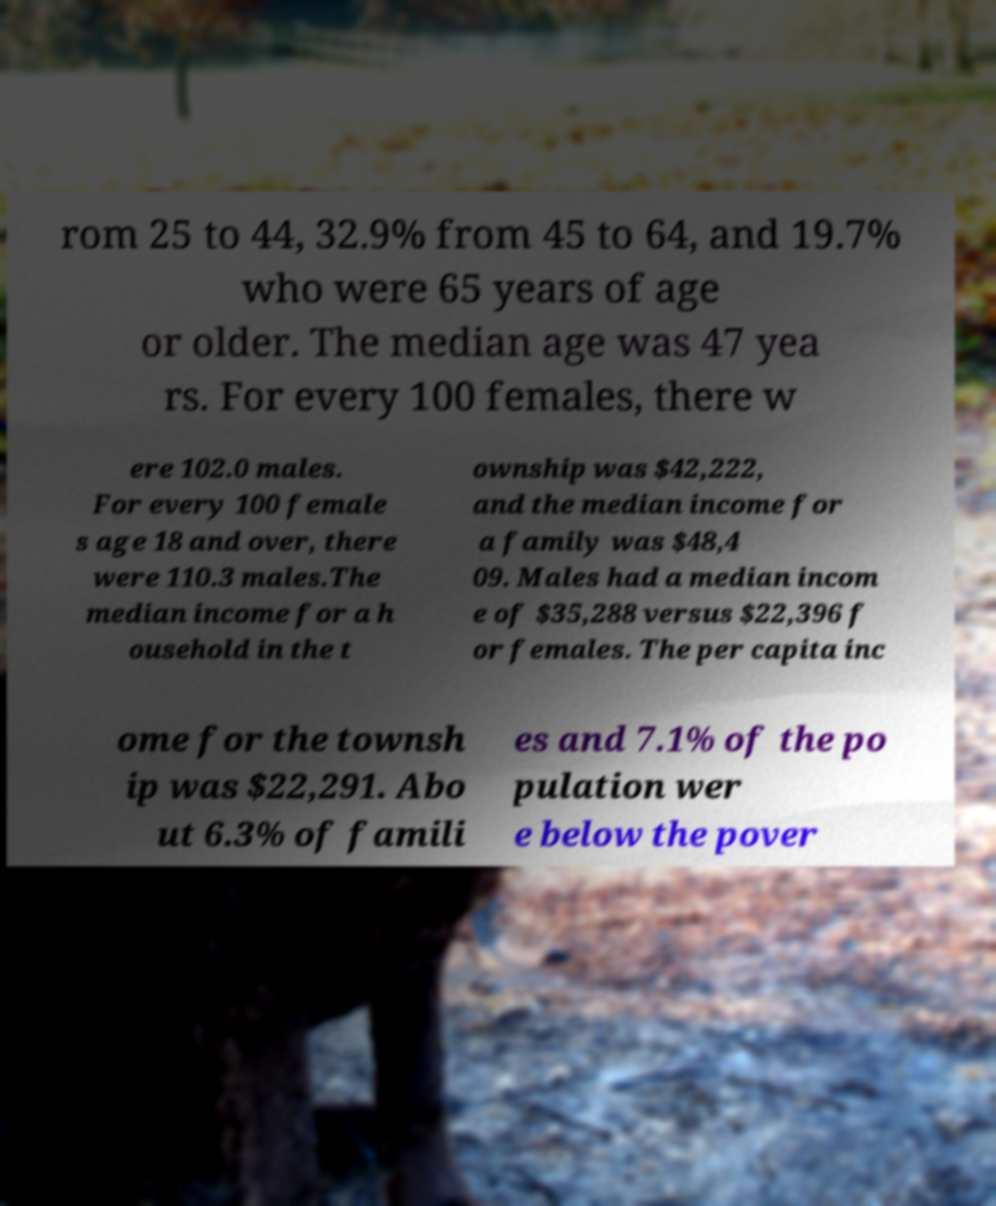I need the written content from this picture converted into text. Can you do that? rom 25 to 44, 32.9% from 45 to 64, and 19.7% who were 65 years of age or older. The median age was 47 yea rs. For every 100 females, there w ere 102.0 males. For every 100 female s age 18 and over, there were 110.3 males.The median income for a h ousehold in the t ownship was $42,222, and the median income for a family was $48,4 09. Males had a median incom e of $35,288 versus $22,396 f or females. The per capita inc ome for the townsh ip was $22,291. Abo ut 6.3% of famili es and 7.1% of the po pulation wer e below the pover 